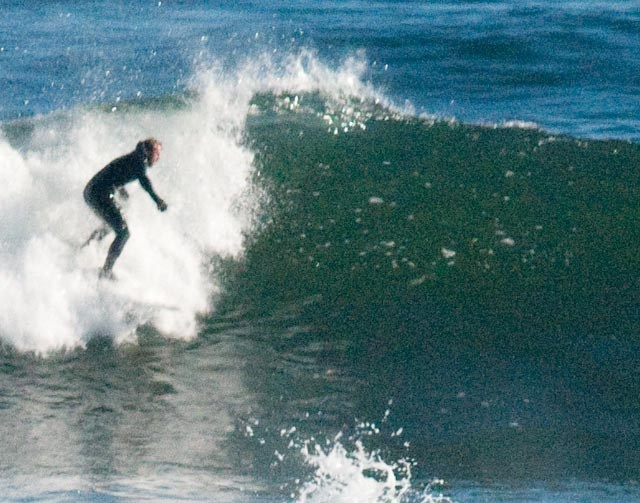Describe the objects in this image and their specific colors. I can see people in teal, navy, gray, lightgray, and darkgray tones and surfboard in teal, lightgray, and darkgray tones in this image. 